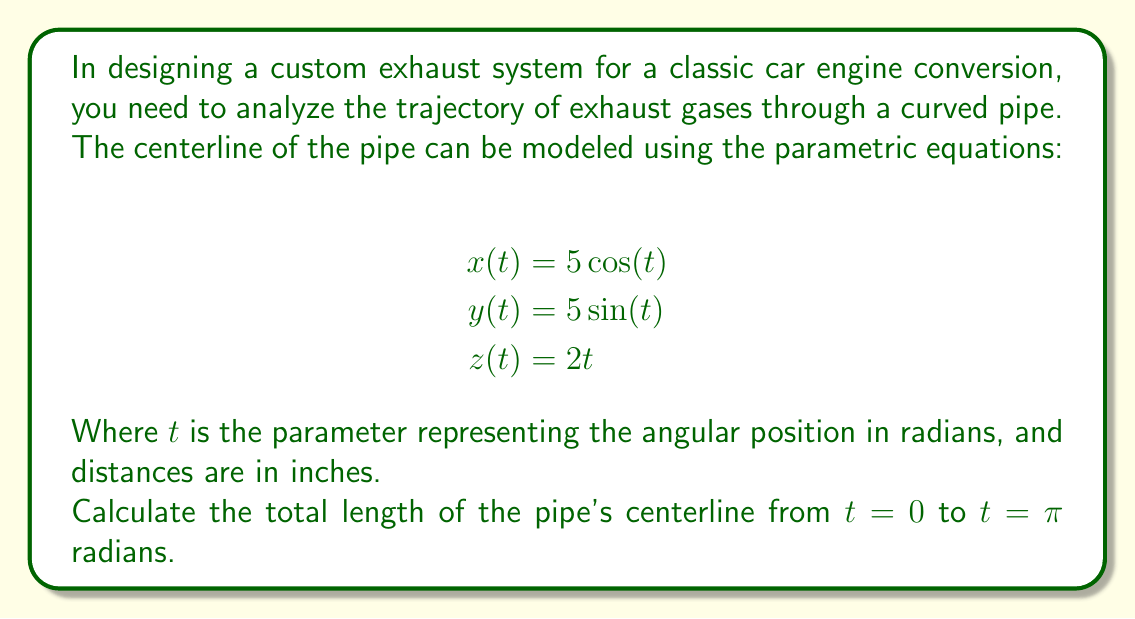Give your solution to this math problem. To find the length of the curve, we need to use the arc length formula for parametric equations in 3D space:

$$L = \int_{a}^{b} \sqrt{\left(\frac{dx}{dt}\right)^2 + \left(\frac{dy}{dt}\right)^2 + \left(\frac{dz}{dt}\right)^2} dt$$

1. First, let's find the derivatives:
   $$\frac{dx}{dt} = -5\sin(t)$$
   $$\frac{dy}{dt} = 5\cos(t)$$
   $$\frac{dz}{dt} = 2$$

2. Now, we square each derivative and sum them:
   $$\left(\frac{dx}{dt}\right)^2 + \left(\frac{dy}{dt}\right)^2 + \left(\frac{dz}{dt}\right)^2 = 25\sin^2(t) + 25\cos^2(t) + 4$$

3. Simplify using the trigonometric identity $\sin^2(t) + \cos^2(t) = 1$:
   $$25(\sin^2(t) + \cos^2(t)) + 4 = 25 + 4 = 29$$

4. Now our integral becomes:
   $$L = \int_{0}^{\pi} \sqrt{29} dt$$

5. Since $\sqrt{29}$ is constant, we can take it out of the integral:
   $$L = \sqrt{29} \int_{0}^{\pi} dt$$

6. Solve the integral:
   $$L = \sqrt{29} [t]_{0}^{\pi} = \sqrt{29} (\pi - 0) = \pi\sqrt{29}$$

Therefore, the length of the pipe's centerline is $\pi\sqrt{29}$ inches.
Answer: $\pi\sqrt{29}$ inches (approximately 16.76 inches) 